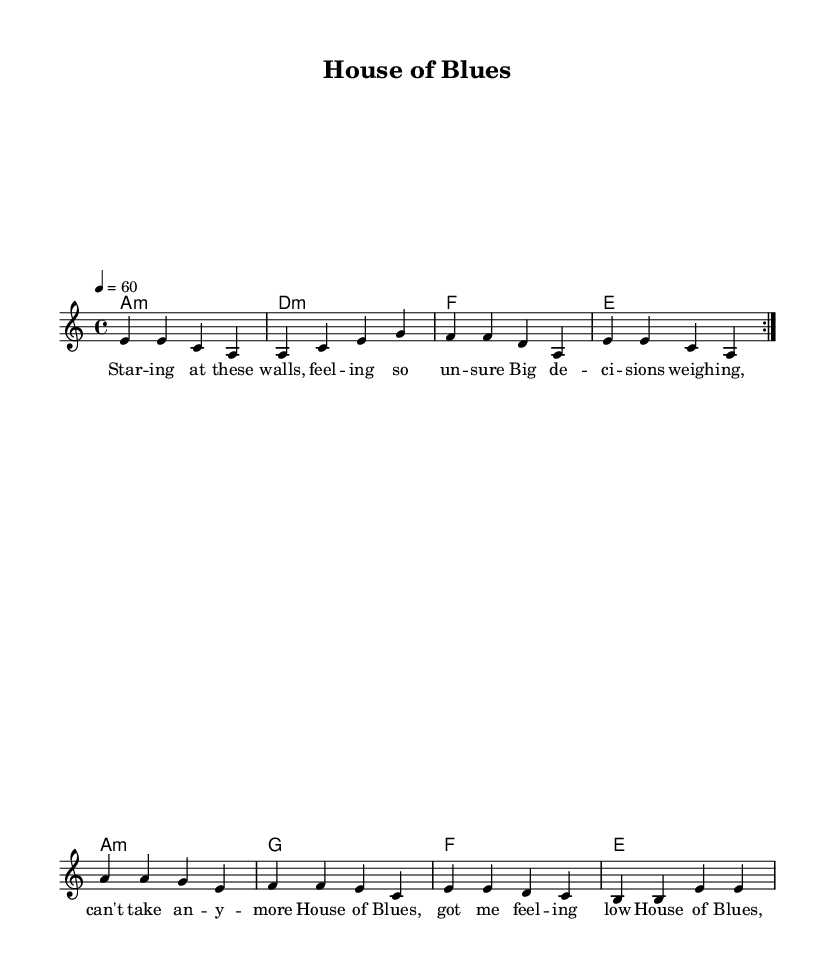What is the key signature of this music? The key signature is A minor, which typically includes no sharps or flats. You can identify the key signature by looking at the left side of the staff where the sharps or flats are indicated. In this case, there's no indication of sharps or flats, confirming the A minor key.
Answer: A minor What is the time signature of this piece? The time signature is 4/4, which means there are four beats in each measure and the quarter note gets one beat. This is specified right at the beginning of the staff, indicating the rhythmic structure of the music.
Answer: 4/4 What is the tempo marking for this composition? The tempo marking is indicated as "4 = 60", which means there are 60 beats per minute at the quarter note level. This tempo is shown above the clef at the beginning of the score, helping performer understand the speed of the piece.
Answer: 60 How many measures are in the melody section? There are eight measures in the melody section. You can determine this by counting the bars from the beginning to the end of the melody line shown on the staff. Each vertical line represents the end of a measure.
Answer: 8 What are the harmonies used in this music? The harmonies used in this music include A minor, D minor, F major, E major, G major. These can be found in the chord mode section of the score that is written above the melody line, showing the chords that accompany it.
Answer: A minor, D minor, F, E, G What is the overall mood of the lyrics presented? The overall mood of the lyrics is introspective and anxious, reflecting feelings of uncertainty regarding financial decisions. This can be inferred from the content of the lyrics which express feelings of doubt and emotional weight connected to major life changes, typical of the blues genre.
Answer: Introspective, anxious What genre does this composition represent? This composition represents the Blues genre, specifically slow and introspective blues ballads, characterized by their reflective lyrics and musical structure. The title "House of Blues" and the emotional content of the lyrics are indicative of the blues style.
Answer: Blues 